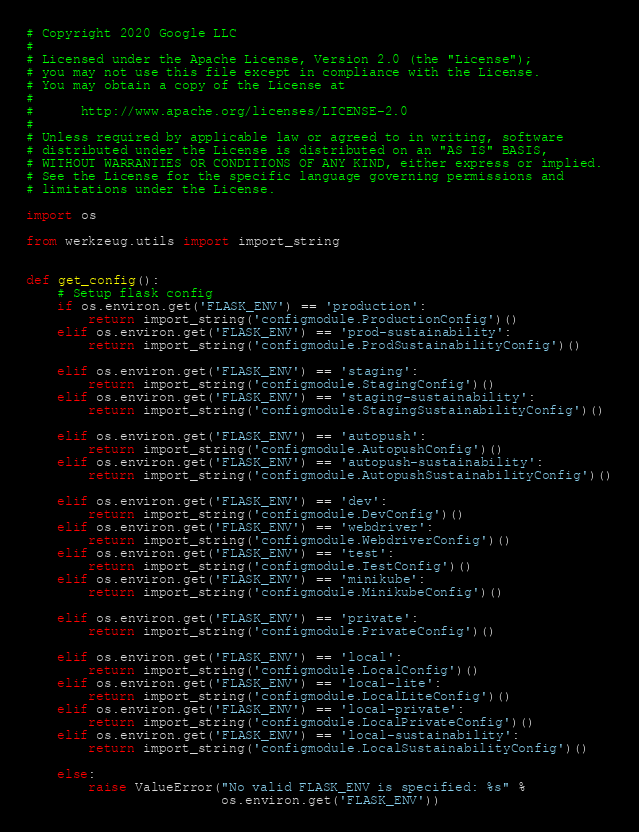Convert code to text. <code><loc_0><loc_0><loc_500><loc_500><_Python_># Copyright 2020 Google LLC
#
# Licensed under the Apache License, Version 2.0 (the "License");
# you may not use this file except in compliance with the License.
# You may obtain a copy of the License at
#
#      http://www.apache.org/licenses/LICENSE-2.0
#
# Unless required by applicable law or agreed to in writing, software
# distributed under the License is distributed on an "AS IS" BASIS,
# WITHOUT WARRANTIES OR CONDITIONS OF ANY KIND, either express or implied.
# See the License for the specific language governing permissions and
# limitations under the License.

import os

from werkzeug.utils import import_string


def get_config():
    # Setup flask config
    if os.environ.get('FLASK_ENV') == 'production':
        return import_string('configmodule.ProductionConfig')()
    elif os.environ.get('FLASK_ENV') == 'prod-sustainability':
        return import_string('configmodule.ProdSustainabilityConfig')()

    elif os.environ.get('FLASK_ENV') == 'staging':
        return import_string('configmodule.StagingConfig')()
    elif os.environ.get('FLASK_ENV') == 'staging-sustainability':
        return import_string('configmodule.StagingSustainabilityConfig')()

    elif os.environ.get('FLASK_ENV') == 'autopush':
        return import_string('configmodule.AutopushConfig')()
    elif os.environ.get('FLASK_ENV') == 'autopush-sustainability':
        return import_string('configmodule.AutopushSustainabilityConfig')()

    elif os.environ.get('FLASK_ENV') == 'dev':
        return import_string('configmodule.DevConfig')()
    elif os.environ.get('FLASK_ENV') == 'webdriver':
        return import_string('configmodule.WebdriverConfig')()
    elif os.environ.get('FLASK_ENV') == 'test':
        return import_string('configmodule.TestConfig')()
    elif os.environ.get('FLASK_ENV') == 'minikube':
        return import_string('configmodule.MinikubeConfig')()

    elif os.environ.get('FLASK_ENV') == 'private':
        return import_string('configmodule.PrivateConfig')()

    elif os.environ.get('FLASK_ENV') == 'local':
        return import_string('configmodule.LocalConfig')()
    elif os.environ.get('FLASK_ENV') == 'local-lite':
        return import_string('configmodule.LocalLiteConfig')()
    elif os.environ.get('FLASK_ENV') == 'local-private':
        return import_string('configmodule.LocalPrivateConfig')()
    elif os.environ.get('FLASK_ENV') == 'local-sustainability':
        return import_string('configmodule.LocalSustainabilityConfig')()

    else:
        raise ValueError("No valid FLASK_ENV is specified: %s" %
                         os.environ.get('FLASK_ENV'))
</code> 